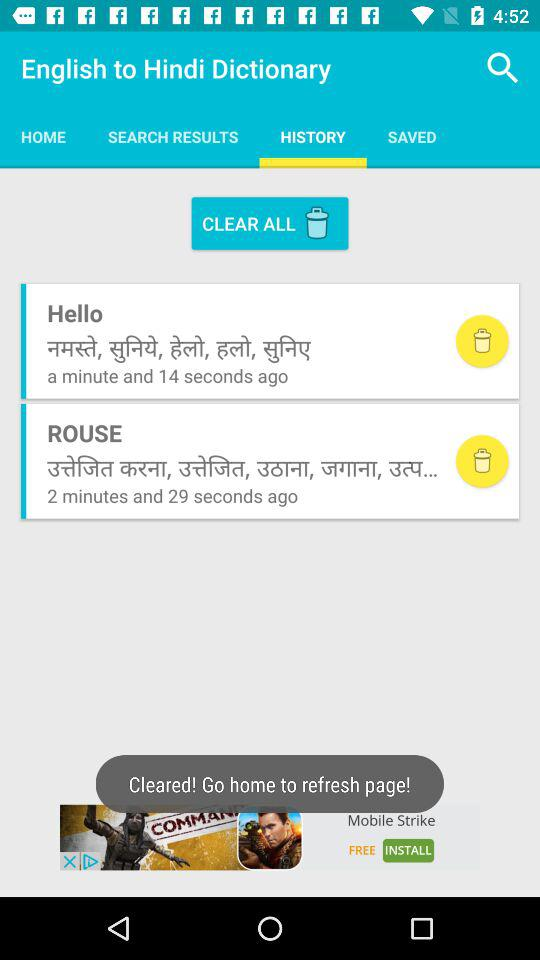Which tab is selected? The selected tab is "HISTORY". 